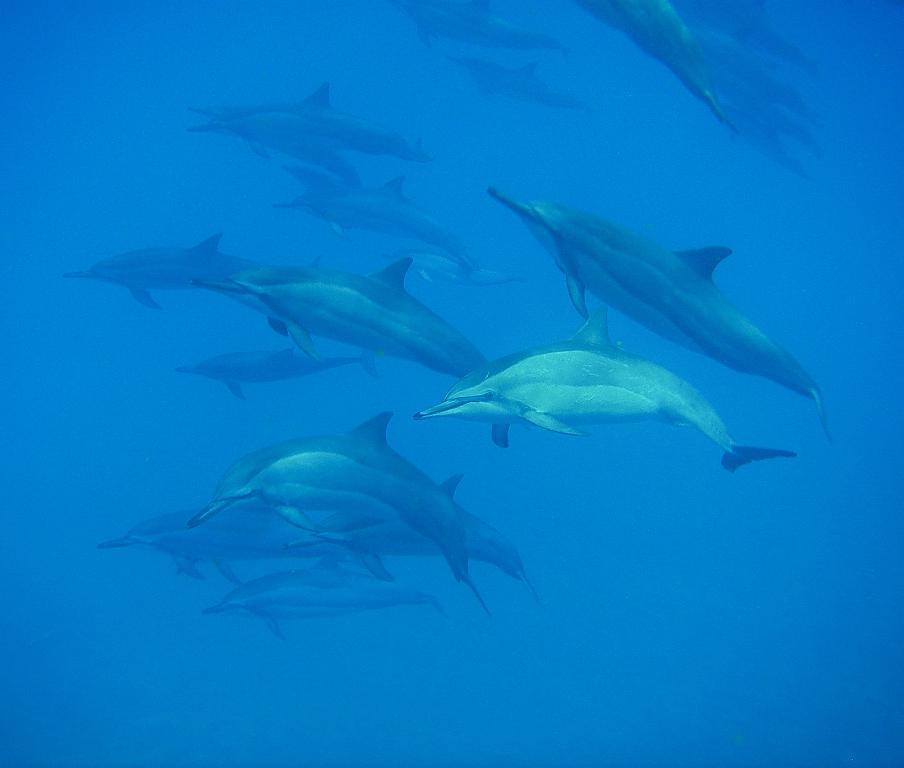Could you give a brief overview of what you see in this image? In this image, we can see fishes in the water. 